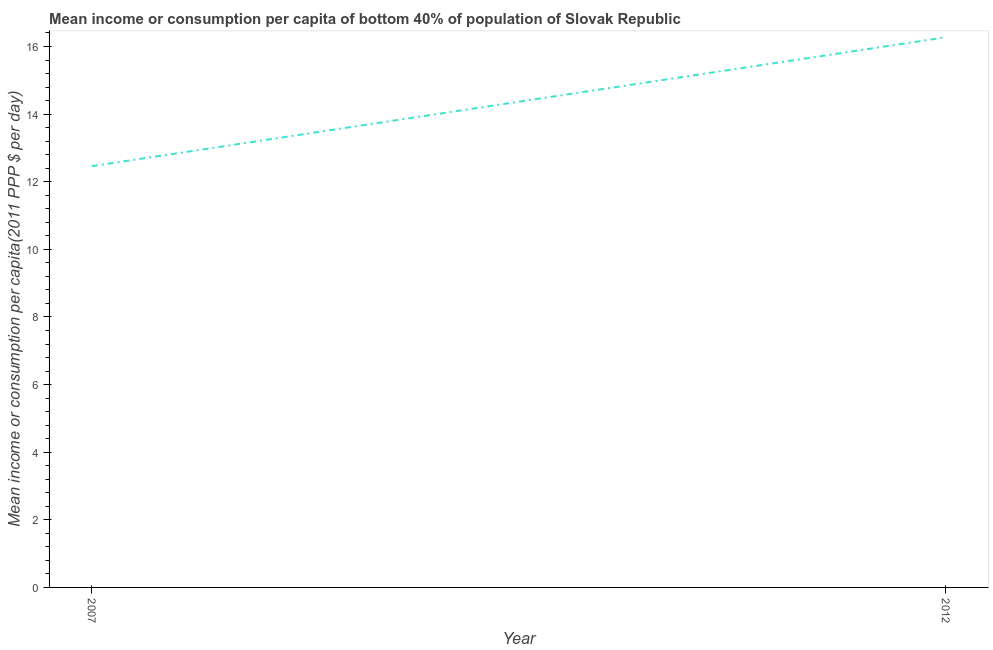What is the mean income or consumption in 2012?
Your response must be concise. 16.27. Across all years, what is the maximum mean income or consumption?
Provide a short and direct response. 16.27. Across all years, what is the minimum mean income or consumption?
Your response must be concise. 12.46. In which year was the mean income or consumption maximum?
Ensure brevity in your answer.  2012. In which year was the mean income or consumption minimum?
Your answer should be compact. 2007. What is the sum of the mean income or consumption?
Ensure brevity in your answer.  28.73. What is the difference between the mean income or consumption in 2007 and 2012?
Provide a short and direct response. -3.81. What is the average mean income or consumption per year?
Keep it short and to the point. 14.37. What is the median mean income or consumption?
Offer a terse response. 14.37. Do a majority of the years between 2012 and 2007 (inclusive) have mean income or consumption greater than 10.8 $?
Give a very brief answer. No. What is the ratio of the mean income or consumption in 2007 to that in 2012?
Ensure brevity in your answer.  0.77. Is the mean income or consumption in 2007 less than that in 2012?
Your answer should be compact. Yes. How many lines are there?
Keep it short and to the point. 1. How many years are there in the graph?
Keep it short and to the point. 2. Are the values on the major ticks of Y-axis written in scientific E-notation?
Give a very brief answer. No. Does the graph contain grids?
Provide a short and direct response. No. What is the title of the graph?
Give a very brief answer. Mean income or consumption per capita of bottom 40% of population of Slovak Republic. What is the label or title of the Y-axis?
Make the answer very short. Mean income or consumption per capita(2011 PPP $ per day). What is the Mean income or consumption per capita(2011 PPP $ per day) in 2007?
Your response must be concise. 12.46. What is the Mean income or consumption per capita(2011 PPP $ per day) of 2012?
Your response must be concise. 16.27. What is the difference between the Mean income or consumption per capita(2011 PPP $ per day) in 2007 and 2012?
Your response must be concise. -3.81. What is the ratio of the Mean income or consumption per capita(2011 PPP $ per day) in 2007 to that in 2012?
Provide a short and direct response. 0.77. 